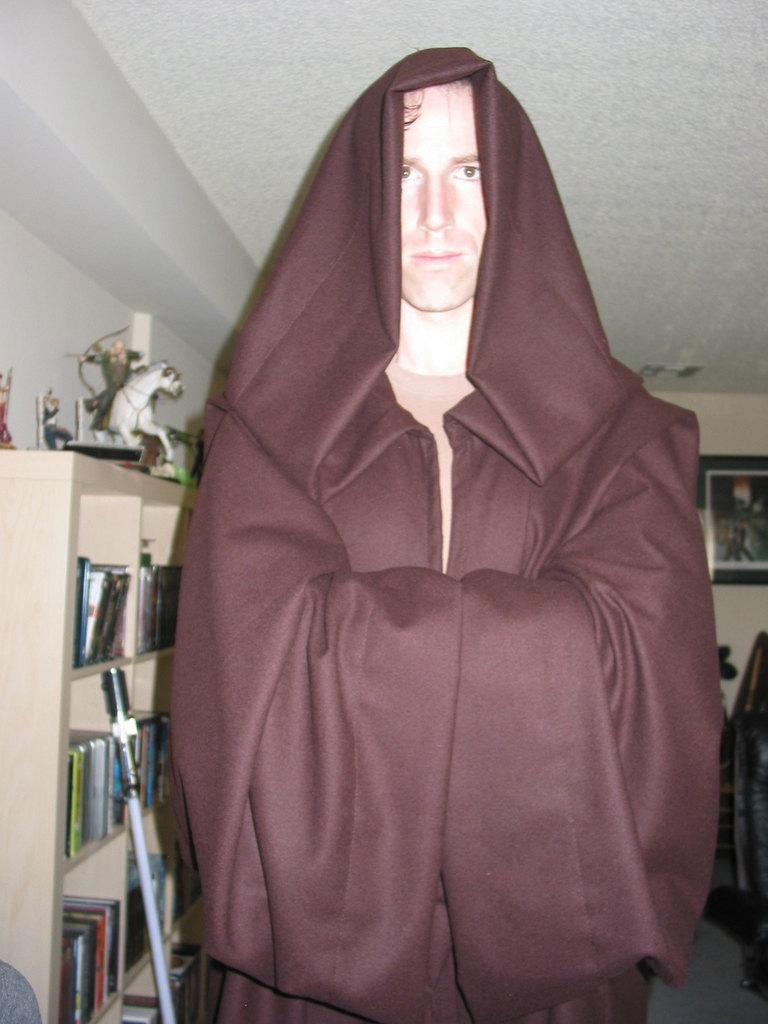What can be seen in the image? There is a person in the image. How is the person dressed or covered? The person is covered with a brown color cloth. What objects can be seen in the background of the image? There is a bookshelf, a statue, and a photograph in the background. What type of pie is being served at the train station in the image? There is no train station or pie present in the image. 